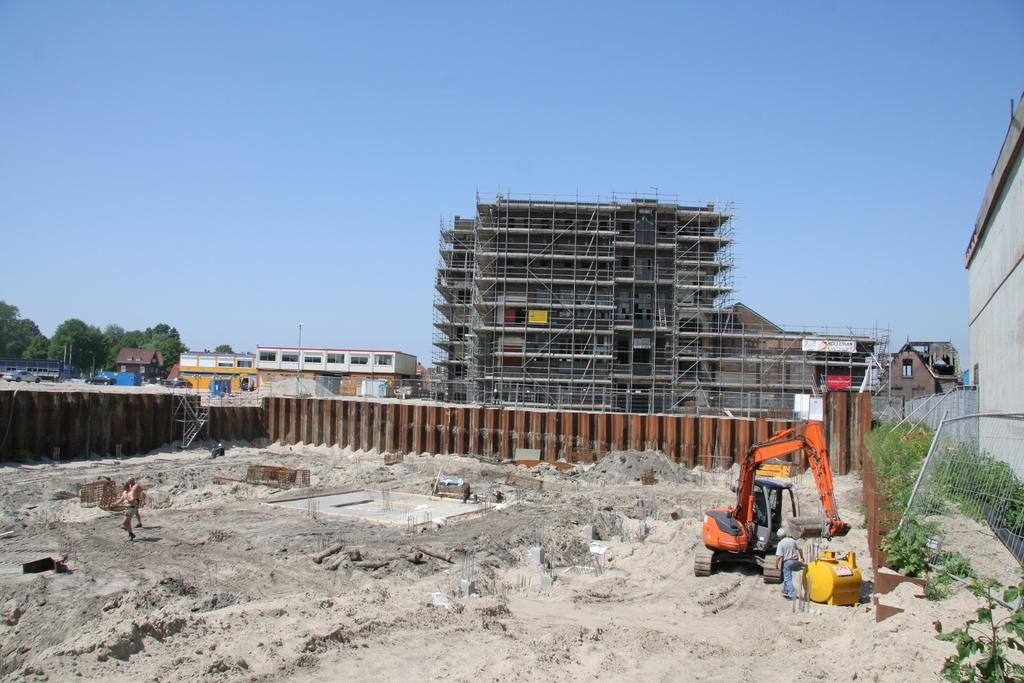What type of structures can be seen in the image? There are buildings in the image. What natural elements are present in the image? There are trees in the image. What man-made objects can be seen in the image? There are vehicles in the image. What type of terrain is visible in the image? There is sand visible in the image. What part of the environment is visible in the image? The sky is visible in the image. What year is depicted in the image? The provided facts do not mention any specific year, so it cannot be determined from the image. What type of quartz can be seen in the image? There is no quartz present in the image. 